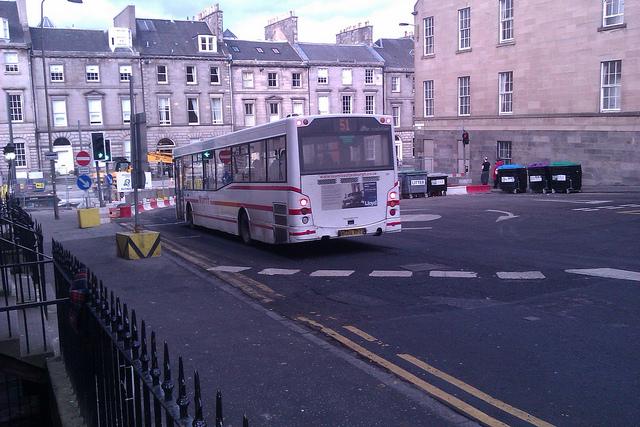How many lanes are on this road?
Be succinct. 1. What color are the concrete bases of the poles painted?
Give a very brief answer. Yellow. What color is the bus?
Be succinct. White. Is the bus driving toward you or away?
Be succinct. Away. What kind of bus is this?
Keep it brief. Passenger. What color are the stripes on the bus?
Answer briefly. Red. Is there a crosswalk here?
Concise answer only. Yes. 